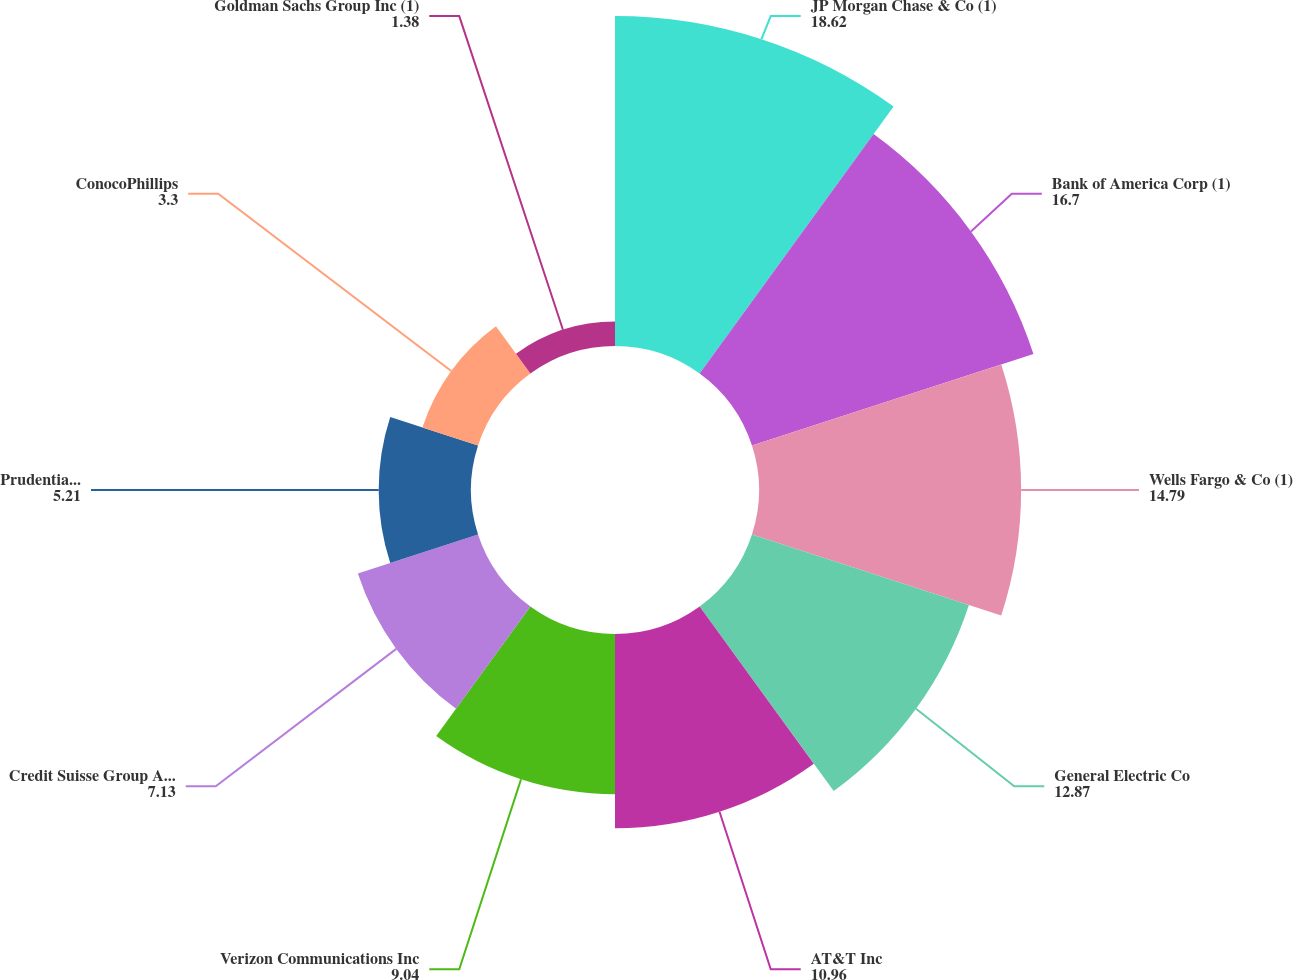Convert chart. <chart><loc_0><loc_0><loc_500><loc_500><pie_chart><fcel>JP Morgan Chase & Co (1)<fcel>Bank of America Corp (1)<fcel>Wells Fargo & Co (1)<fcel>General Electric Co<fcel>AT&T Inc<fcel>Verizon Communications Inc<fcel>Credit Suisse Group AG (1)<fcel>Prudential Financial Inc<fcel>ConocoPhillips<fcel>Goldman Sachs Group Inc (1)<nl><fcel>18.62%<fcel>16.7%<fcel>14.79%<fcel>12.87%<fcel>10.96%<fcel>9.04%<fcel>7.13%<fcel>5.21%<fcel>3.3%<fcel>1.38%<nl></chart> 